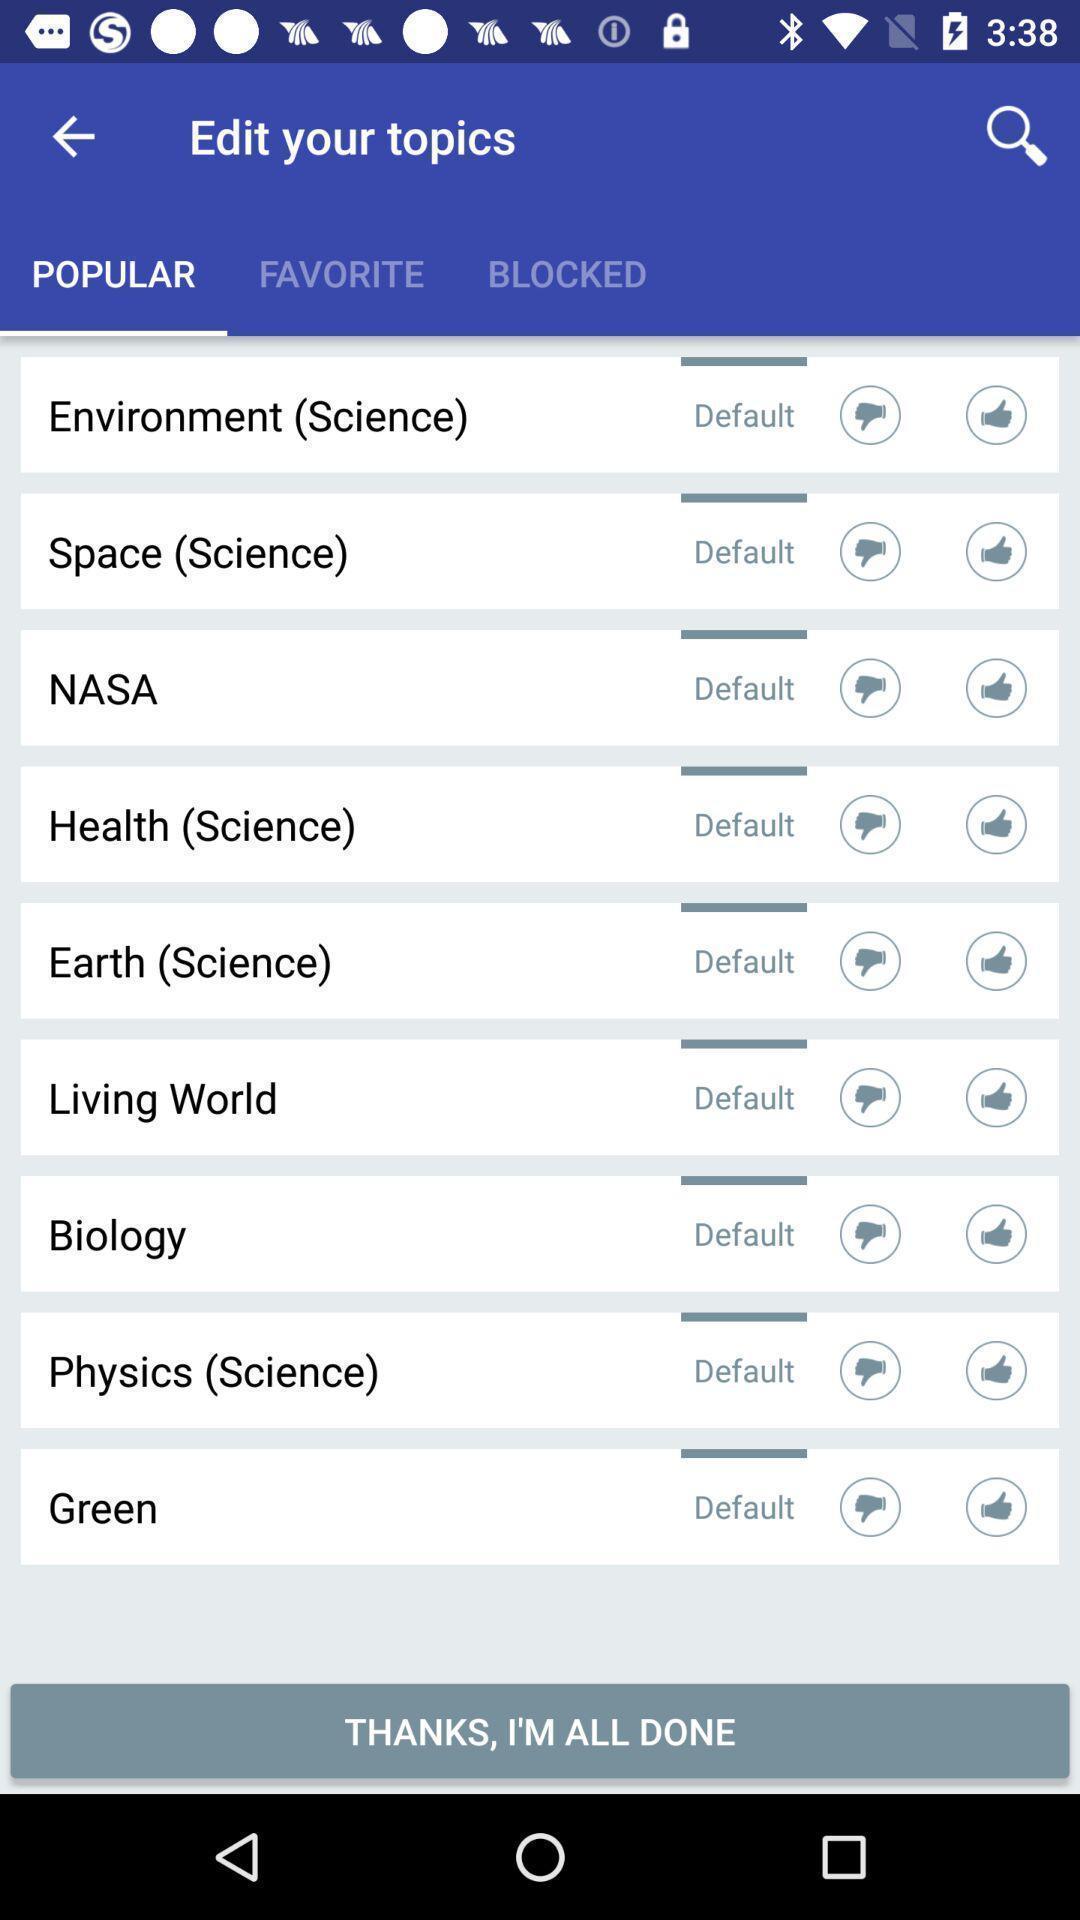Tell me what you see in this picture. Page shows to select your topic in the study app. 